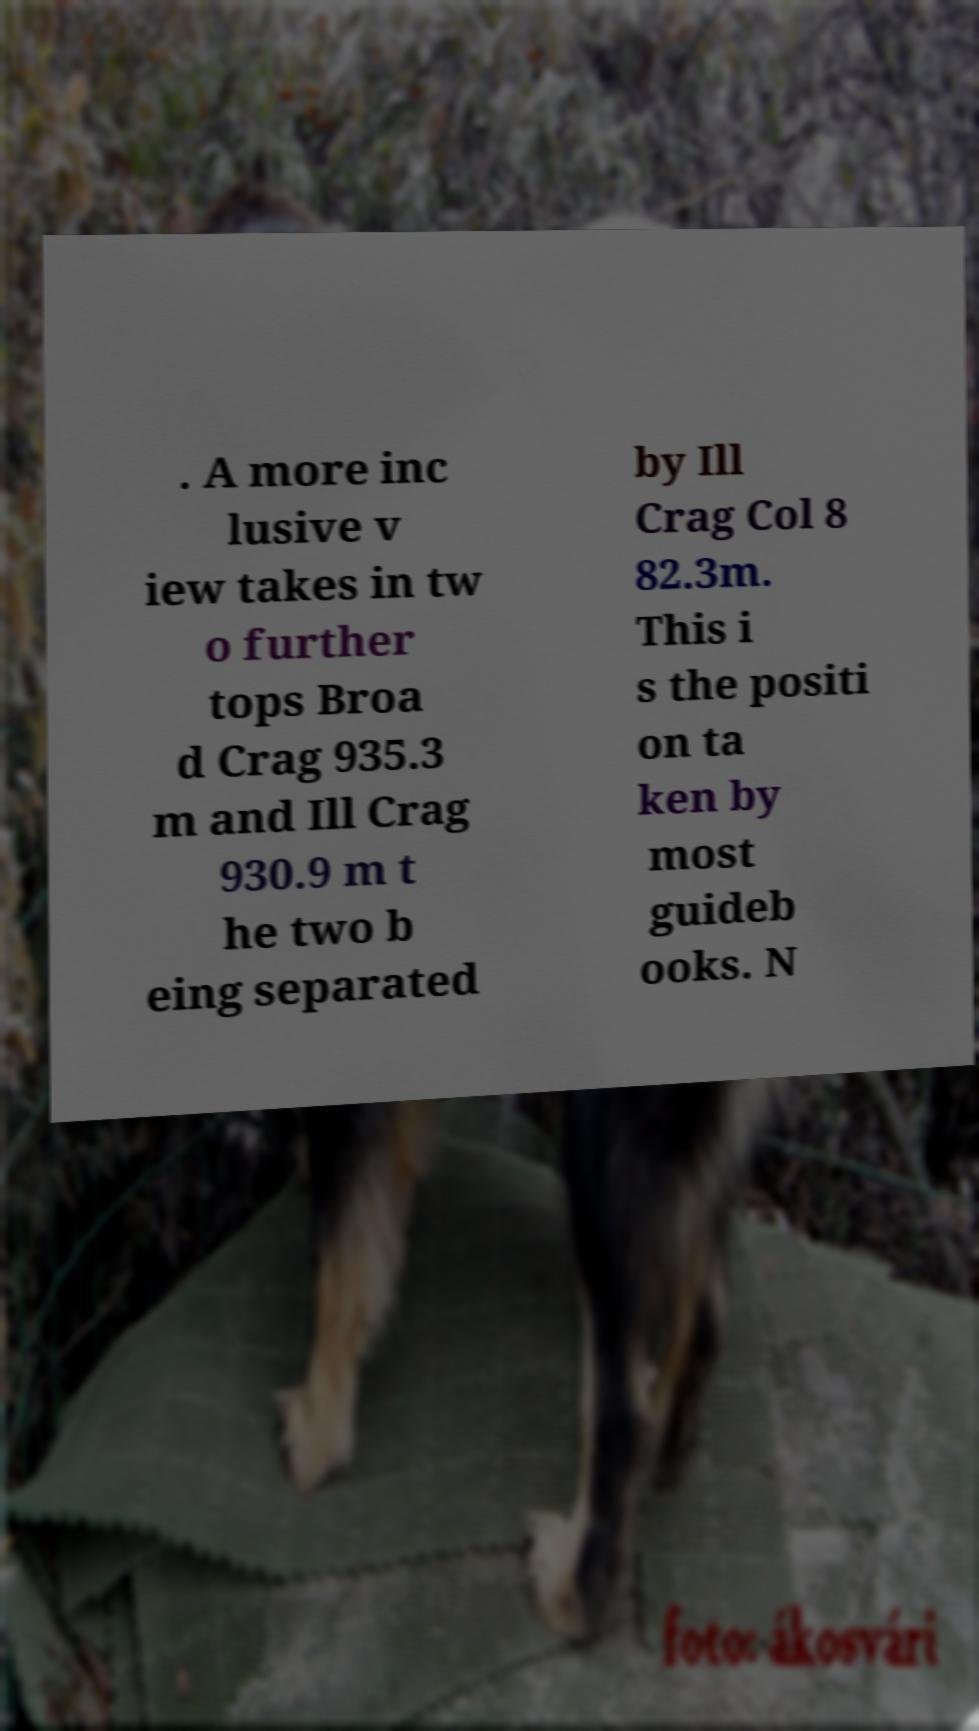What messages or text are displayed in this image? I need them in a readable, typed format. . A more inc lusive v iew takes in tw o further tops Broa d Crag 935.3 m and Ill Crag 930.9 m t he two b eing separated by Ill Crag Col 8 82.3m. This i s the positi on ta ken by most guideb ooks. N 